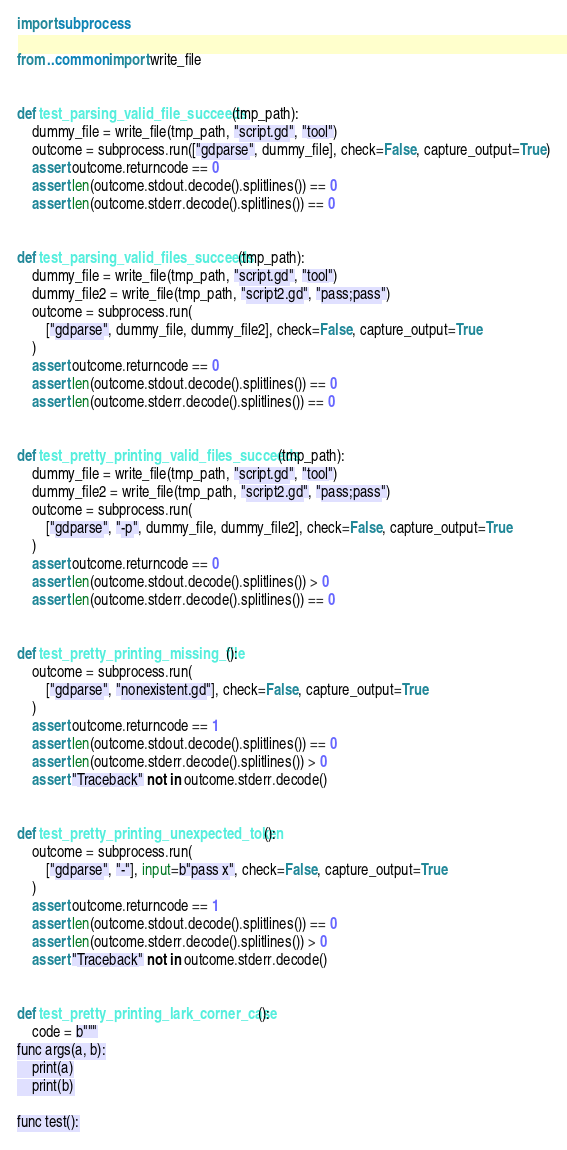Convert code to text. <code><loc_0><loc_0><loc_500><loc_500><_Python_>import subprocess

from ..common import write_file


def test_parsing_valid_file_succeeds(tmp_path):
    dummy_file = write_file(tmp_path, "script.gd", "tool")
    outcome = subprocess.run(["gdparse", dummy_file], check=False, capture_output=True)
    assert outcome.returncode == 0
    assert len(outcome.stdout.decode().splitlines()) == 0
    assert len(outcome.stderr.decode().splitlines()) == 0


def test_parsing_valid_files_succeeds(tmp_path):
    dummy_file = write_file(tmp_path, "script.gd", "tool")
    dummy_file2 = write_file(tmp_path, "script2.gd", "pass;pass")
    outcome = subprocess.run(
        ["gdparse", dummy_file, dummy_file2], check=False, capture_output=True
    )
    assert outcome.returncode == 0
    assert len(outcome.stdout.decode().splitlines()) == 0
    assert len(outcome.stderr.decode().splitlines()) == 0


def test_pretty_printing_valid_files_succeeds(tmp_path):
    dummy_file = write_file(tmp_path, "script.gd", "tool")
    dummy_file2 = write_file(tmp_path, "script2.gd", "pass;pass")
    outcome = subprocess.run(
        ["gdparse", "-p", dummy_file, dummy_file2], check=False, capture_output=True
    )
    assert outcome.returncode == 0
    assert len(outcome.stdout.decode().splitlines()) > 0
    assert len(outcome.stderr.decode().splitlines()) == 0


def test_pretty_printing_missing_file():
    outcome = subprocess.run(
        ["gdparse", "nonexistent.gd"], check=False, capture_output=True
    )
    assert outcome.returncode == 1
    assert len(outcome.stdout.decode().splitlines()) == 0
    assert len(outcome.stderr.decode().splitlines()) > 0
    assert "Traceback" not in outcome.stderr.decode()


def test_pretty_printing_unexpected_token():
    outcome = subprocess.run(
        ["gdparse", "-"], input=b"pass x", check=False, capture_output=True
    )
    assert outcome.returncode == 1
    assert len(outcome.stdout.decode().splitlines()) == 0
    assert len(outcome.stderr.decode().splitlines()) > 0
    assert "Traceback" not in outcome.stderr.decode()


def test_pretty_printing_lark_corner_case():
    code = b"""
func args(a, b):
	print(a)
	print(b)

func test():</code> 